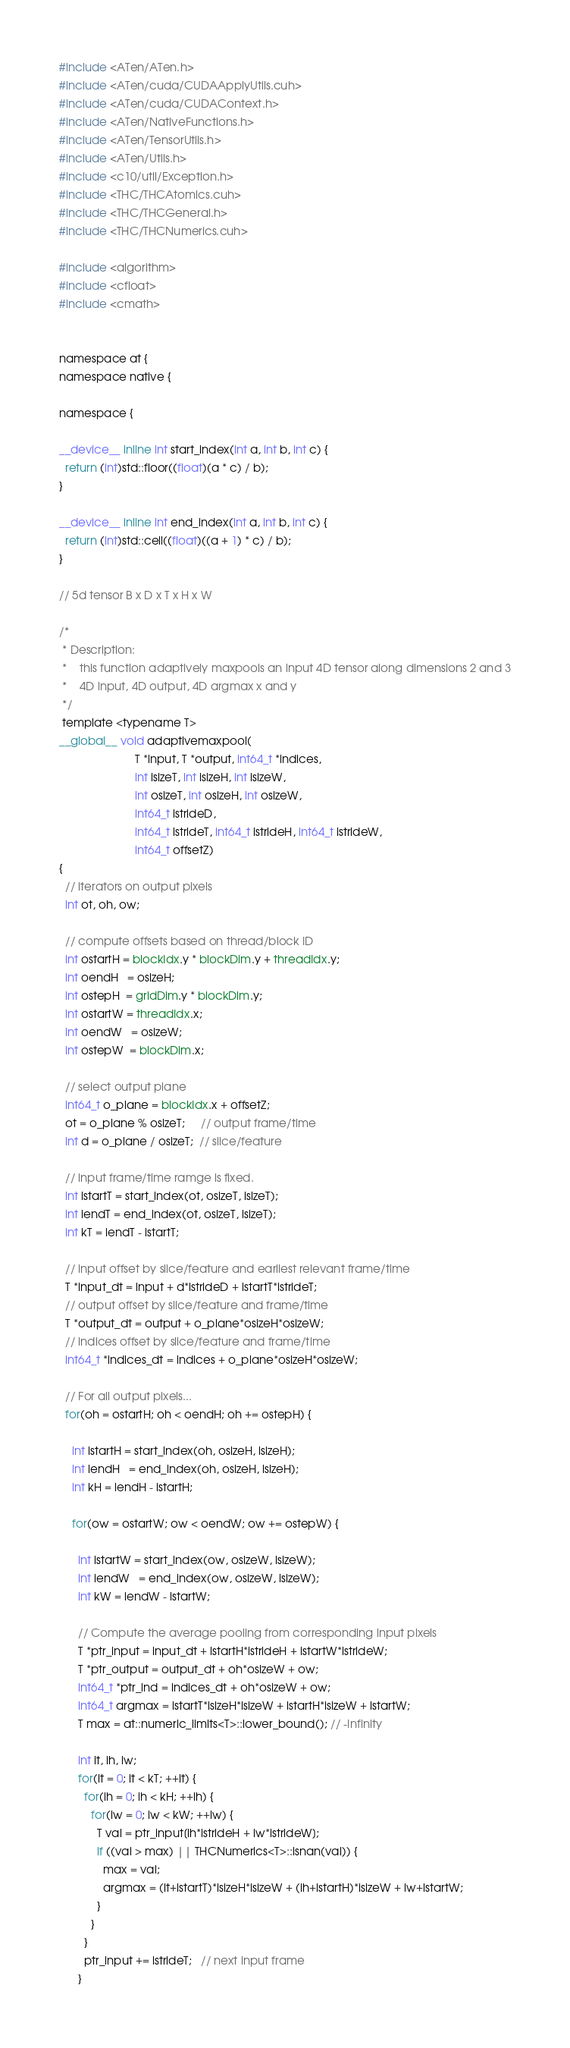Convert code to text. <code><loc_0><loc_0><loc_500><loc_500><_Cuda_>#include <ATen/ATen.h>
#include <ATen/cuda/CUDAApplyUtils.cuh>
#include <ATen/cuda/CUDAContext.h>
#include <ATen/NativeFunctions.h>
#include <ATen/TensorUtils.h>
#include <ATen/Utils.h>
#include <c10/util/Exception.h>
#include <THC/THCAtomics.cuh>
#include <THC/THCGeneral.h>
#include <THC/THCNumerics.cuh>

#include <algorithm>
#include <cfloat>
#include <cmath>


namespace at {
namespace native {

namespace {

__device__ inline int start_index(int a, int b, int c) {
  return (int)std::floor((float)(a * c) / b);
}

__device__ inline int end_index(int a, int b, int c) {
  return (int)std::ceil((float)((a + 1) * c) / b);
}

// 5d tensor B x D x T x H x W

/*
 * Description:
 *    this function adaptively maxpools an input 4D tensor along dimensions 2 and 3
 *    4D input, 4D output, 4D argmax x and y
 */
 template <typename T>
__global__ void adaptivemaxpool(
                        T *input, T *output, int64_t *indices,
                        int isizeT, int isizeH, int isizeW,
                        int osizeT, int osizeH, int osizeW,
                        int64_t istrideD,
                        int64_t istrideT, int64_t istrideH, int64_t istrideW,
                        int64_t offsetZ)
{
  // iterators on output pixels
  int ot, oh, ow;

  // compute offsets based on thread/block ID
  int ostartH = blockIdx.y * blockDim.y + threadIdx.y;
  int oendH   = osizeH;
  int ostepH  = gridDim.y * blockDim.y;
  int ostartW = threadIdx.x;
  int oendW   = osizeW;
  int ostepW  = blockDim.x;

  // select output plane
  int64_t o_plane = blockIdx.x + offsetZ;
  ot = o_plane % osizeT;     // output frame/time
  int d = o_plane / osizeT;  // slice/feature

  // input frame/time ramge is fixed.
  int istartT = start_index(ot, osizeT, isizeT);
  int iendT = end_index(ot, osizeT, isizeT);
  int kT = iendT - istartT;

  // input offset by slice/feature and earliest relevant frame/time
  T *input_dt = input + d*istrideD + istartT*istrideT;
  // output offset by slice/feature and frame/time
  T *output_dt = output + o_plane*osizeH*osizeW;
  // indices offset by slice/feature and frame/time
  int64_t *indices_dt = indices + o_plane*osizeH*osizeW;

  // For all output pixels...
  for(oh = ostartH; oh < oendH; oh += ostepH) {

    int istartH = start_index(oh, osizeH, isizeH);
    int iendH   = end_index(oh, osizeH, isizeH);
    int kH = iendH - istartH;

    for(ow = ostartW; ow < oendW; ow += ostepW) {

      int istartW = start_index(ow, osizeW, isizeW);
      int iendW   = end_index(ow, osizeW, isizeW);
      int kW = iendW - istartW;

      // Compute the average pooling from corresponding input pixels
      T *ptr_input = input_dt + istartH*istrideH + istartW*istrideW;
      T *ptr_output = output_dt + oh*osizeW + ow;
      int64_t *ptr_ind = indices_dt + oh*osizeW + ow;
      int64_t argmax = istartT*isizeH*isizeW + istartH*isizeW + istartW;
      T max = at::numeric_limits<T>::lower_bound(); // -Infinity

      int it, ih, iw;
      for(it = 0; it < kT; ++it) {
        for(ih = 0; ih < kH; ++ih) {
          for(iw = 0; iw < kW; ++iw) {
            T val = ptr_input[ih*istrideH + iw*istrideW];
            if ((val > max) || THCNumerics<T>::isnan(val)) {
              max = val;
              argmax = (it+istartT)*isizeH*isizeW + (ih+istartH)*isizeW + iw+istartW;
            }
          }
        }
        ptr_input += istrideT;   // next input frame
      }</code> 